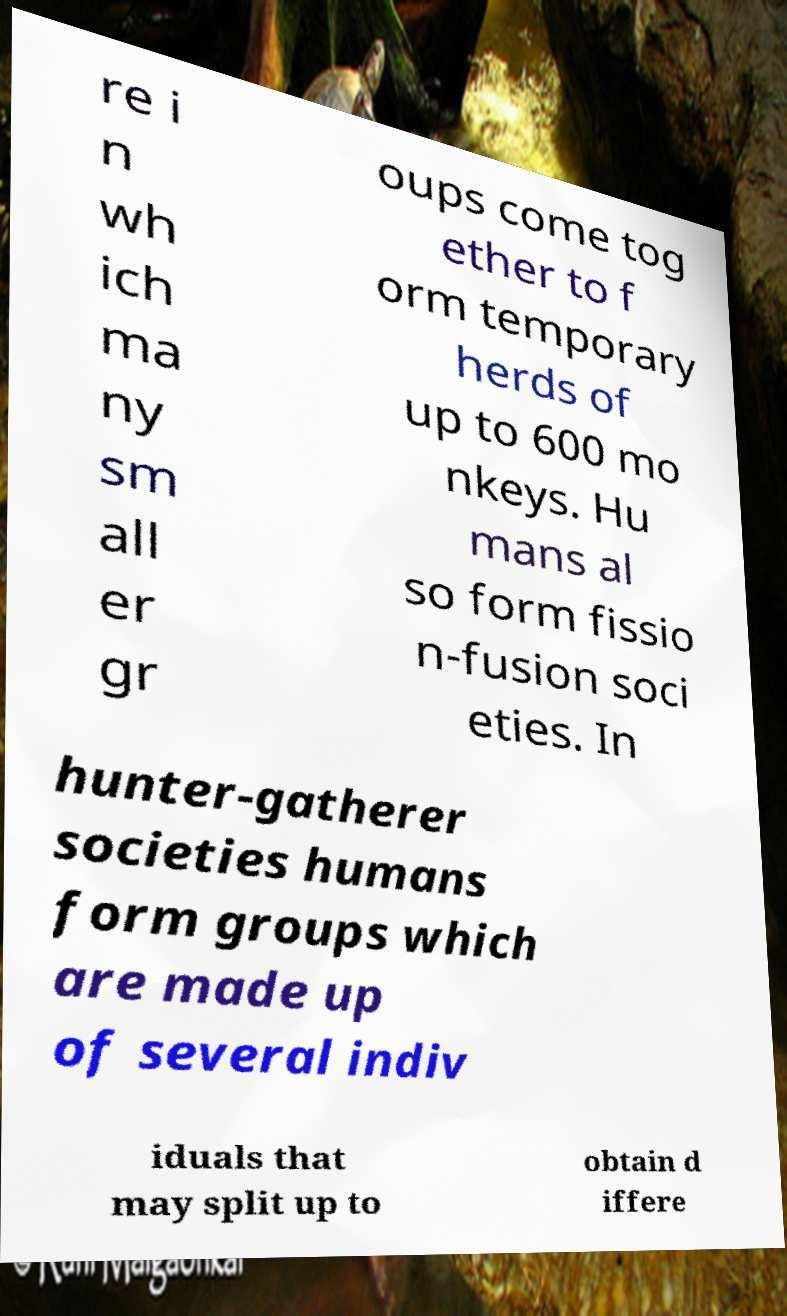What messages or text are displayed in this image? I need them in a readable, typed format. re i n wh ich ma ny sm all er gr oups come tog ether to f orm temporary herds of up to 600 mo nkeys. Hu mans al so form fissio n-fusion soci eties. In hunter-gatherer societies humans form groups which are made up of several indiv iduals that may split up to obtain d iffere 